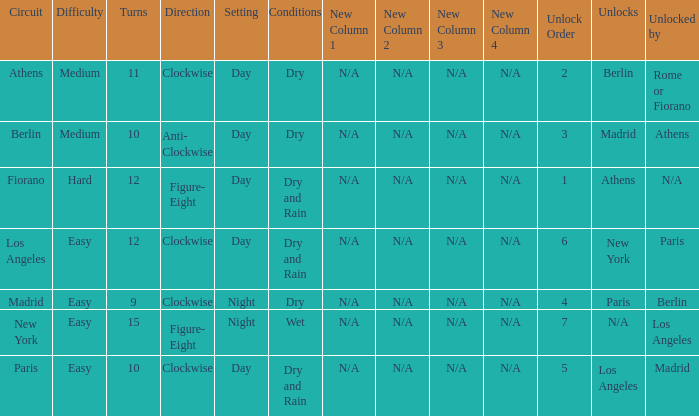What are the conditions for the athens circuit? Dry. 